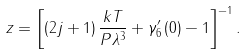Convert formula to latex. <formula><loc_0><loc_0><loc_500><loc_500>z = \left [ \left ( 2 j + 1 \right ) \frac { k T } { P \lambda ^ { 3 } } + \gamma _ { 6 } ^ { \prime } \left ( 0 \right ) - 1 \right ] ^ { - 1 } .</formula> 